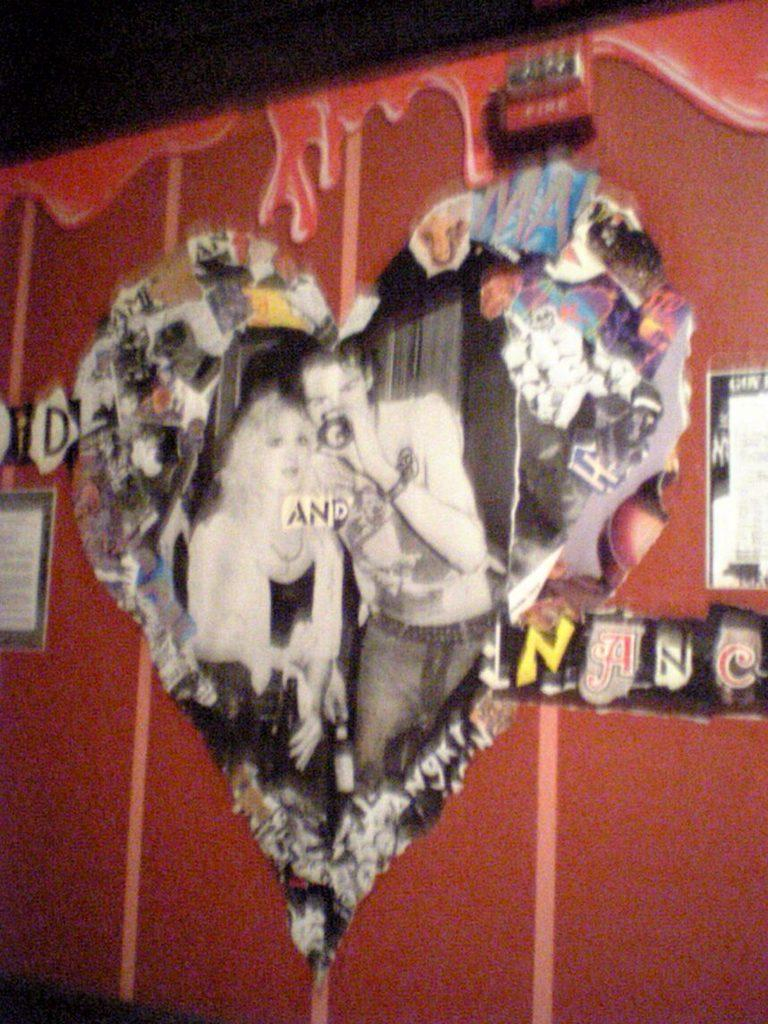What can be seen on the wall in the image? There are posters on the wall in the image. Can you describe the lighting in the top part of the image? The top part of the image is dark. What type of jeans are visible on the bookshelf in the image? There are no jeans present in the image. How many coughs can be heard in the image? There are no sounds, including coughs, present in the image. 